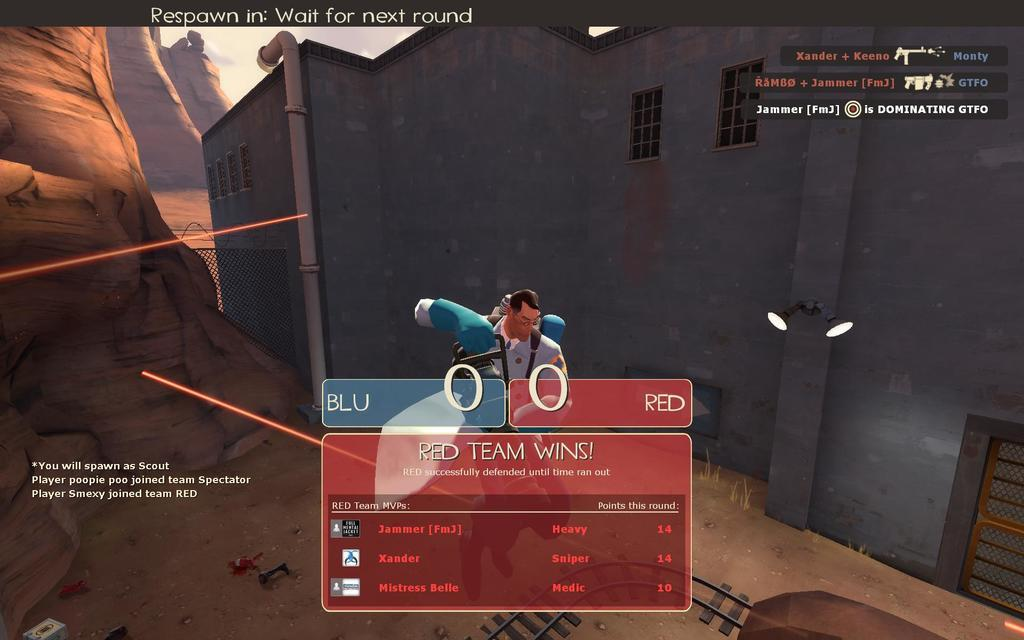What is the main subject of the image? The main subject of the image is a screenshot. What type of garden can be seen in the image? There is no garden present in the image; it features a screenshot. How many teeth are visible in the image? There are no teeth visible in the image; it features a screenshot. 